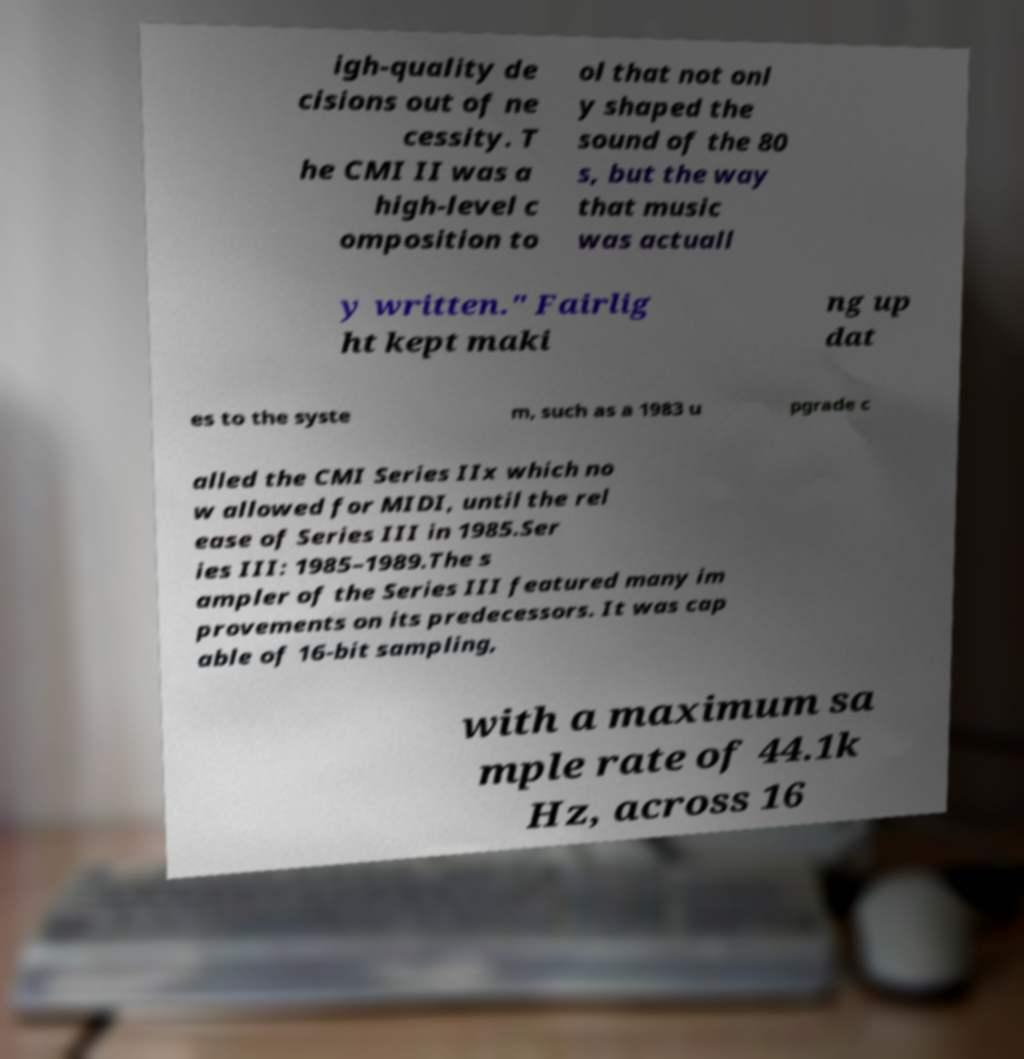Could you extract and type out the text from this image? igh-quality de cisions out of ne cessity. T he CMI II was a high-level c omposition to ol that not onl y shaped the sound of the 80 s, but the way that music was actuall y written." Fairlig ht kept maki ng up dat es to the syste m, such as a 1983 u pgrade c alled the CMI Series IIx which no w allowed for MIDI, until the rel ease of Series III in 1985.Ser ies III: 1985–1989.The s ampler of the Series III featured many im provements on its predecessors. It was cap able of 16-bit sampling, with a maximum sa mple rate of 44.1k Hz, across 16 